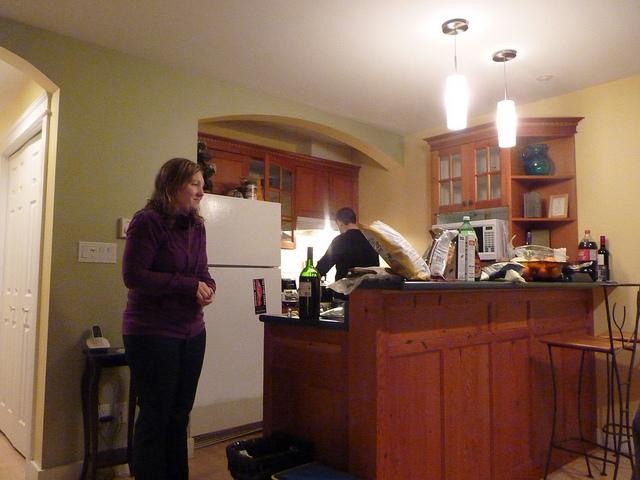What is on the ceiling?
Write a very short answer. Lights. How many people are there?
Answer briefly. 2. What drink is in the far back?
Write a very short answer. Coke. What brand are the potato chips?
Keep it brief. Lays. 